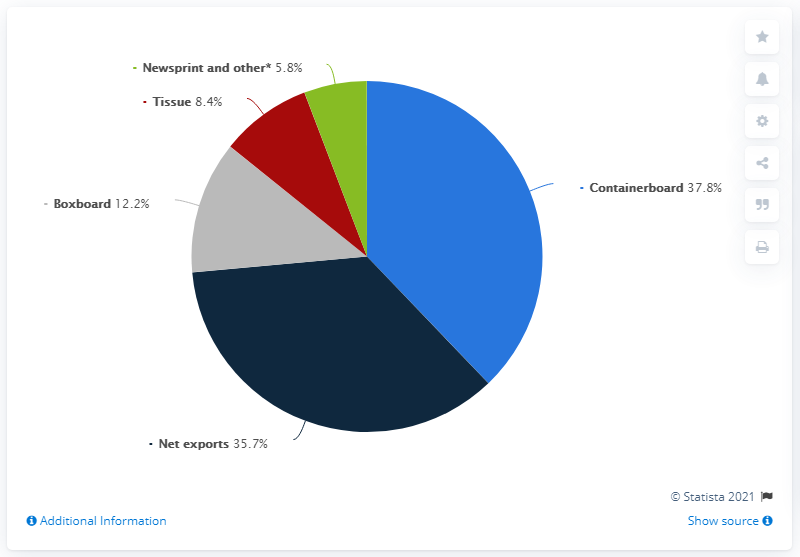Specify some key components in this picture. The ratio of the second smallest segment to the gray segment is 0.689... The green segment has a percentage value of 5.8. 